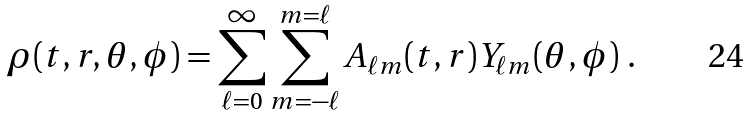Convert formula to latex. <formula><loc_0><loc_0><loc_500><loc_500>\rho ( t , r , \theta , \phi ) = \sum _ { \ell = 0 } ^ { \infty } \sum _ { m = - \ell } ^ { m = \ell } A _ { \ell m } ( t , r ) Y _ { \ell m } ( \theta , \phi ) \ .</formula> 